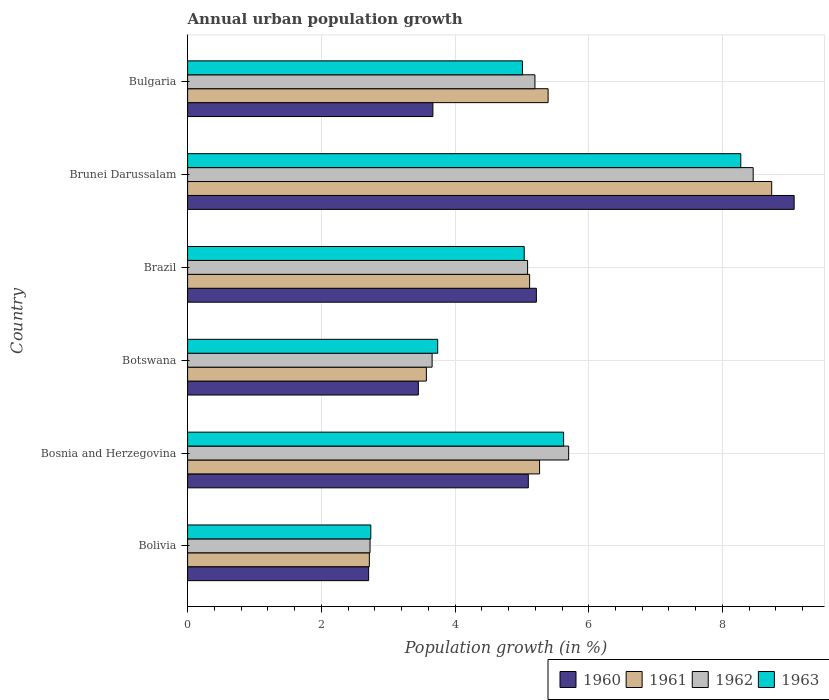How many different coloured bars are there?
Your answer should be very brief. 4. How many groups of bars are there?
Ensure brevity in your answer.  6. How many bars are there on the 6th tick from the bottom?
Offer a terse response. 4. What is the label of the 3rd group of bars from the top?
Keep it short and to the point. Brazil. What is the percentage of urban population growth in 1962 in Botswana?
Make the answer very short. 3.66. Across all countries, what is the maximum percentage of urban population growth in 1960?
Keep it short and to the point. 9.07. Across all countries, what is the minimum percentage of urban population growth in 1960?
Keep it short and to the point. 2.71. In which country was the percentage of urban population growth in 1960 maximum?
Your answer should be very brief. Brunei Darussalam. In which country was the percentage of urban population growth in 1960 minimum?
Provide a succinct answer. Bolivia. What is the total percentage of urban population growth in 1961 in the graph?
Your answer should be very brief. 30.8. What is the difference between the percentage of urban population growth in 1961 in Bosnia and Herzegovina and that in Botswana?
Your response must be concise. 1.69. What is the difference between the percentage of urban population growth in 1963 in Bulgaria and the percentage of urban population growth in 1960 in Bosnia and Herzegovina?
Offer a very short reply. -0.09. What is the average percentage of urban population growth in 1962 per country?
Provide a short and direct response. 5.14. What is the difference between the percentage of urban population growth in 1962 and percentage of urban population growth in 1961 in Bolivia?
Ensure brevity in your answer.  0.01. What is the ratio of the percentage of urban population growth in 1962 in Brazil to that in Brunei Darussalam?
Give a very brief answer. 0.6. Is the difference between the percentage of urban population growth in 1962 in Brunei Darussalam and Bulgaria greater than the difference between the percentage of urban population growth in 1961 in Brunei Darussalam and Bulgaria?
Keep it short and to the point. No. What is the difference between the highest and the second highest percentage of urban population growth in 1963?
Keep it short and to the point. 2.65. What is the difference between the highest and the lowest percentage of urban population growth in 1962?
Your answer should be compact. 5.73. In how many countries, is the percentage of urban population growth in 1962 greater than the average percentage of urban population growth in 1962 taken over all countries?
Make the answer very short. 3. Is it the case that in every country, the sum of the percentage of urban population growth in 1960 and percentage of urban population growth in 1962 is greater than the sum of percentage of urban population growth in 1961 and percentage of urban population growth in 1963?
Make the answer very short. No. How many bars are there?
Offer a terse response. 24. How many countries are there in the graph?
Your answer should be compact. 6. How many legend labels are there?
Provide a short and direct response. 4. How are the legend labels stacked?
Your answer should be compact. Horizontal. What is the title of the graph?
Make the answer very short. Annual urban population growth. What is the label or title of the X-axis?
Your answer should be compact. Population growth (in %). What is the Population growth (in %) in 1960 in Bolivia?
Give a very brief answer. 2.71. What is the Population growth (in %) in 1961 in Bolivia?
Your answer should be very brief. 2.72. What is the Population growth (in %) of 1962 in Bolivia?
Your answer should be very brief. 2.73. What is the Population growth (in %) in 1963 in Bolivia?
Your answer should be compact. 2.74. What is the Population growth (in %) of 1960 in Bosnia and Herzegovina?
Offer a very short reply. 5.1. What is the Population growth (in %) in 1961 in Bosnia and Herzegovina?
Your response must be concise. 5.26. What is the Population growth (in %) of 1962 in Bosnia and Herzegovina?
Provide a short and direct response. 5.7. What is the Population growth (in %) in 1963 in Bosnia and Herzegovina?
Your response must be concise. 5.62. What is the Population growth (in %) of 1960 in Botswana?
Offer a very short reply. 3.45. What is the Population growth (in %) in 1961 in Botswana?
Your answer should be compact. 3.57. What is the Population growth (in %) of 1962 in Botswana?
Your response must be concise. 3.66. What is the Population growth (in %) of 1963 in Botswana?
Keep it short and to the point. 3.74. What is the Population growth (in %) in 1960 in Brazil?
Ensure brevity in your answer.  5.22. What is the Population growth (in %) of 1961 in Brazil?
Give a very brief answer. 5.12. What is the Population growth (in %) of 1962 in Brazil?
Make the answer very short. 5.09. What is the Population growth (in %) in 1963 in Brazil?
Offer a terse response. 5.03. What is the Population growth (in %) in 1960 in Brunei Darussalam?
Ensure brevity in your answer.  9.07. What is the Population growth (in %) of 1961 in Brunei Darussalam?
Keep it short and to the point. 8.74. What is the Population growth (in %) of 1962 in Brunei Darussalam?
Offer a terse response. 8.46. What is the Population growth (in %) of 1963 in Brunei Darussalam?
Your response must be concise. 8.27. What is the Population growth (in %) in 1960 in Bulgaria?
Ensure brevity in your answer.  3.67. What is the Population growth (in %) of 1961 in Bulgaria?
Keep it short and to the point. 5.39. What is the Population growth (in %) in 1962 in Bulgaria?
Keep it short and to the point. 5.2. What is the Population growth (in %) in 1963 in Bulgaria?
Make the answer very short. 5.01. Across all countries, what is the maximum Population growth (in %) in 1960?
Give a very brief answer. 9.07. Across all countries, what is the maximum Population growth (in %) of 1961?
Keep it short and to the point. 8.74. Across all countries, what is the maximum Population growth (in %) in 1962?
Offer a terse response. 8.46. Across all countries, what is the maximum Population growth (in %) of 1963?
Your answer should be compact. 8.27. Across all countries, what is the minimum Population growth (in %) of 1960?
Your answer should be very brief. 2.71. Across all countries, what is the minimum Population growth (in %) of 1961?
Offer a terse response. 2.72. Across all countries, what is the minimum Population growth (in %) in 1962?
Offer a terse response. 2.73. Across all countries, what is the minimum Population growth (in %) of 1963?
Provide a succinct answer. 2.74. What is the total Population growth (in %) in 1960 in the graph?
Provide a short and direct response. 29.21. What is the total Population growth (in %) in 1961 in the graph?
Ensure brevity in your answer.  30.8. What is the total Population growth (in %) of 1962 in the graph?
Provide a short and direct response. 30.82. What is the total Population growth (in %) in 1963 in the graph?
Your answer should be compact. 30.42. What is the difference between the Population growth (in %) of 1960 in Bolivia and that in Bosnia and Herzegovina?
Your response must be concise. -2.39. What is the difference between the Population growth (in %) of 1961 in Bolivia and that in Bosnia and Herzegovina?
Provide a short and direct response. -2.55. What is the difference between the Population growth (in %) of 1962 in Bolivia and that in Bosnia and Herzegovina?
Give a very brief answer. -2.97. What is the difference between the Population growth (in %) of 1963 in Bolivia and that in Bosnia and Herzegovina?
Provide a succinct answer. -2.88. What is the difference between the Population growth (in %) of 1960 in Bolivia and that in Botswana?
Provide a succinct answer. -0.74. What is the difference between the Population growth (in %) in 1961 in Bolivia and that in Botswana?
Give a very brief answer. -0.85. What is the difference between the Population growth (in %) in 1962 in Bolivia and that in Botswana?
Provide a short and direct response. -0.93. What is the difference between the Population growth (in %) of 1963 in Bolivia and that in Botswana?
Your answer should be compact. -1. What is the difference between the Population growth (in %) in 1960 in Bolivia and that in Brazil?
Offer a terse response. -2.51. What is the difference between the Population growth (in %) of 1961 in Bolivia and that in Brazil?
Ensure brevity in your answer.  -2.4. What is the difference between the Population growth (in %) of 1962 in Bolivia and that in Brazil?
Make the answer very short. -2.36. What is the difference between the Population growth (in %) in 1963 in Bolivia and that in Brazil?
Your response must be concise. -2.29. What is the difference between the Population growth (in %) in 1960 in Bolivia and that in Brunei Darussalam?
Your answer should be compact. -6.36. What is the difference between the Population growth (in %) of 1961 in Bolivia and that in Brunei Darussalam?
Your answer should be compact. -6.02. What is the difference between the Population growth (in %) in 1962 in Bolivia and that in Brunei Darussalam?
Your response must be concise. -5.73. What is the difference between the Population growth (in %) of 1963 in Bolivia and that in Brunei Darussalam?
Your answer should be compact. -5.53. What is the difference between the Population growth (in %) of 1960 in Bolivia and that in Bulgaria?
Provide a short and direct response. -0.96. What is the difference between the Population growth (in %) in 1961 in Bolivia and that in Bulgaria?
Your answer should be compact. -2.67. What is the difference between the Population growth (in %) of 1962 in Bolivia and that in Bulgaria?
Provide a succinct answer. -2.47. What is the difference between the Population growth (in %) in 1963 in Bolivia and that in Bulgaria?
Provide a short and direct response. -2.27. What is the difference between the Population growth (in %) in 1960 in Bosnia and Herzegovina and that in Botswana?
Offer a very short reply. 1.64. What is the difference between the Population growth (in %) in 1961 in Bosnia and Herzegovina and that in Botswana?
Provide a short and direct response. 1.69. What is the difference between the Population growth (in %) of 1962 in Bosnia and Herzegovina and that in Botswana?
Make the answer very short. 2.04. What is the difference between the Population growth (in %) in 1963 in Bosnia and Herzegovina and that in Botswana?
Your response must be concise. 1.88. What is the difference between the Population growth (in %) of 1960 in Bosnia and Herzegovina and that in Brazil?
Provide a succinct answer. -0.12. What is the difference between the Population growth (in %) in 1961 in Bosnia and Herzegovina and that in Brazil?
Give a very brief answer. 0.15. What is the difference between the Population growth (in %) of 1962 in Bosnia and Herzegovina and that in Brazil?
Give a very brief answer. 0.61. What is the difference between the Population growth (in %) in 1963 in Bosnia and Herzegovina and that in Brazil?
Offer a terse response. 0.59. What is the difference between the Population growth (in %) of 1960 in Bosnia and Herzegovina and that in Brunei Darussalam?
Your answer should be compact. -3.98. What is the difference between the Population growth (in %) in 1961 in Bosnia and Herzegovina and that in Brunei Darussalam?
Your answer should be compact. -3.47. What is the difference between the Population growth (in %) of 1962 in Bosnia and Herzegovina and that in Brunei Darussalam?
Your answer should be compact. -2.76. What is the difference between the Population growth (in %) of 1963 in Bosnia and Herzegovina and that in Brunei Darussalam?
Keep it short and to the point. -2.65. What is the difference between the Population growth (in %) in 1960 in Bosnia and Herzegovina and that in Bulgaria?
Make the answer very short. 1.43. What is the difference between the Population growth (in %) in 1961 in Bosnia and Herzegovina and that in Bulgaria?
Offer a very short reply. -0.13. What is the difference between the Population growth (in %) of 1962 in Bosnia and Herzegovina and that in Bulgaria?
Give a very brief answer. 0.5. What is the difference between the Population growth (in %) of 1963 in Bosnia and Herzegovina and that in Bulgaria?
Provide a short and direct response. 0.62. What is the difference between the Population growth (in %) of 1960 in Botswana and that in Brazil?
Give a very brief answer. -1.76. What is the difference between the Population growth (in %) in 1961 in Botswana and that in Brazil?
Ensure brevity in your answer.  -1.54. What is the difference between the Population growth (in %) of 1962 in Botswana and that in Brazil?
Keep it short and to the point. -1.43. What is the difference between the Population growth (in %) of 1963 in Botswana and that in Brazil?
Your answer should be compact. -1.29. What is the difference between the Population growth (in %) of 1960 in Botswana and that in Brunei Darussalam?
Keep it short and to the point. -5.62. What is the difference between the Population growth (in %) in 1961 in Botswana and that in Brunei Darussalam?
Offer a very short reply. -5.16. What is the difference between the Population growth (in %) of 1962 in Botswana and that in Brunei Darussalam?
Offer a terse response. -4.8. What is the difference between the Population growth (in %) in 1963 in Botswana and that in Brunei Darussalam?
Keep it short and to the point. -4.53. What is the difference between the Population growth (in %) of 1960 in Botswana and that in Bulgaria?
Provide a succinct answer. -0.22. What is the difference between the Population growth (in %) of 1961 in Botswana and that in Bulgaria?
Your response must be concise. -1.82. What is the difference between the Population growth (in %) of 1962 in Botswana and that in Bulgaria?
Provide a succinct answer. -1.54. What is the difference between the Population growth (in %) in 1963 in Botswana and that in Bulgaria?
Provide a short and direct response. -1.27. What is the difference between the Population growth (in %) of 1960 in Brazil and that in Brunei Darussalam?
Keep it short and to the point. -3.86. What is the difference between the Population growth (in %) of 1961 in Brazil and that in Brunei Darussalam?
Provide a short and direct response. -3.62. What is the difference between the Population growth (in %) of 1962 in Brazil and that in Brunei Darussalam?
Your answer should be very brief. -3.37. What is the difference between the Population growth (in %) of 1963 in Brazil and that in Brunei Darussalam?
Make the answer very short. -3.24. What is the difference between the Population growth (in %) in 1960 in Brazil and that in Bulgaria?
Give a very brief answer. 1.55. What is the difference between the Population growth (in %) in 1961 in Brazil and that in Bulgaria?
Your response must be concise. -0.28. What is the difference between the Population growth (in %) in 1962 in Brazil and that in Bulgaria?
Make the answer very short. -0.11. What is the difference between the Population growth (in %) in 1963 in Brazil and that in Bulgaria?
Keep it short and to the point. 0.03. What is the difference between the Population growth (in %) of 1960 in Brunei Darussalam and that in Bulgaria?
Ensure brevity in your answer.  5.4. What is the difference between the Population growth (in %) of 1961 in Brunei Darussalam and that in Bulgaria?
Ensure brevity in your answer.  3.34. What is the difference between the Population growth (in %) of 1962 in Brunei Darussalam and that in Bulgaria?
Ensure brevity in your answer.  3.26. What is the difference between the Population growth (in %) in 1963 in Brunei Darussalam and that in Bulgaria?
Offer a very short reply. 3.27. What is the difference between the Population growth (in %) of 1960 in Bolivia and the Population growth (in %) of 1961 in Bosnia and Herzegovina?
Give a very brief answer. -2.56. What is the difference between the Population growth (in %) in 1960 in Bolivia and the Population growth (in %) in 1962 in Bosnia and Herzegovina?
Your answer should be very brief. -2.99. What is the difference between the Population growth (in %) in 1960 in Bolivia and the Population growth (in %) in 1963 in Bosnia and Herzegovina?
Provide a short and direct response. -2.92. What is the difference between the Population growth (in %) in 1961 in Bolivia and the Population growth (in %) in 1962 in Bosnia and Herzegovina?
Provide a short and direct response. -2.98. What is the difference between the Population growth (in %) of 1961 in Bolivia and the Population growth (in %) of 1963 in Bosnia and Herzegovina?
Ensure brevity in your answer.  -2.91. What is the difference between the Population growth (in %) in 1962 in Bolivia and the Population growth (in %) in 1963 in Bosnia and Herzegovina?
Provide a short and direct response. -2.9. What is the difference between the Population growth (in %) in 1960 in Bolivia and the Population growth (in %) in 1961 in Botswana?
Ensure brevity in your answer.  -0.86. What is the difference between the Population growth (in %) of 1960 in Bolivia and the Population growth (in %) of 1962 in Botswana?
Your answer should be very brief. -0.95. What is the difference between the Population growth (in %) in 1960 in Bolivia and the Population growth (in %) in 1963 in Botswana?
Your answer should be compact. -1.03. What is the difference between the Population growth (in %) of 1961 in Bolivia and the Population growth (in %) of 1962 in Botswana?
Ensure brevity in your answer.  -0.94. What is the difference between the Population growth (in %) of 1961 in Bolivia and the Population growth (in %) of 1963 in Botswana?
Give a very brief answer. -1.02. What is the difference between the Population growth (in %) in 1962 in Bolivia and the Population growth (in %) in 1963 in Botswana?
Give a very brief answer. -1.01. What is the difference between the Population growth (in %) of 1960 in Bolivia and the Population growth (in %) of 1961 in Brazil?
Offer a terse response. -2.41. What is the difference between the Population growth (in %) of 1960 in Bolivia and the Population growth (in %) of 1962 in Brazil?
Ensure brevity in your answer.  -2.38. What is the difference between the Population growth (in %) in 1960 in Bolivia and the Population growth (in %) in 1963 in Brazil?
Your response must be concise. -2.33. What is the difference between the Population growth (in %) in 1961 in Bolivia and the Population growth (in %) in 1962 in Brazil?
Provide a short and direct response. -2.37. What is the difference between the Population growth (in %) in 1961 in Bolivia and the Population growth (in %) in 1963 in Brazil?
Keep it short and to the point. -2.32. What is the difference between the Population growth (in %) in 1962 in Bolivia and the Population growth (in %) in 1963 in Brazil?
Provide a short and direct response. -2.31. What is the difference between the Population growth (in %) in 1960 in Bolivia and the Population growth (in %) in 1961 in Brunei Darussalam?
Make the answer very short. -6.03. What is the difference between the Population growth (in %) of 1960 in Bolivia and the Population growth (in %) of 1962 in Brunei Darussalam?
Give a very brief answer. -5.75. What is the difference between the Population growth (in %) of 1960 in Bolivia and the Population growth (in %) of 1963 in Brunei Darussalam?
Offer a terse response. -5.57. What is the difference between the Population growth (in %) in 1961 in Bolivia and the Population growth (in %) in 1962 in Brunei Darussalam?
Ensure brevity in your answer.  -5.74. What is the difference between the Population growth (in %) of 1961 in Bolivia and the Population growth (in %) of 1963 in Brunei Darussalam?
Keep it short and to the point. -5.56. What is the difference between the Population growth (in %) in 1962 in Bolivia and the Population growth (in %) in 1963 in Brunei Darussalam?
Your answer should be compact. -5.55. What is the difference between the Population growth (in %) in 1960 in Bolivia and the Population growth (in %) in 1961 in Bulgaria?
Your response must be concise. -2.68. What is the difference between the Population growth (in %) of 1960 in Bolivia and the Population growth (in %) of 1962 in Bulgaria?
Give a very brief answer. -2.49. What is the difference between the Population growth (in %) in 1960 in Bolivia and the Population growth (in %) in 1963 in Bulgaria?
Ensure brevity in your answer.  -2.3. What is the difference between the Population growth (in %) of 1961 in Bolivia and the Population growth (in %) of 1962 in Bulgaria?
Make the answer very short. -2.48. What is the difference between the Population growth (in %) of 1961 in Bolivia and the Population growth (in %) of 1963 in Bulgaria?
Give a very brief answer. -2.29. What is the difference between the Population growth (in %) in 1962 in Bolivia and the Population growth (in %) in 1963 in Bulgaria?
Provide a succinct answer. -2.28. What is the difference between the Population growth (in %) of 1960 in Bosnia and Herzegovina and the Population growth (in %) of 1961 in Botswana?
Offer a very short reply. 1.52. What is the difference between the Population growth (in %) of 1960 in Bosnia and Herzegovina and the Population growth (in %) of 1962 in Botswana?
Your response must be concise. 1.44. What is the difference between the Population growth (in %) in 1960 in Bosnia and Herzegovina and the Population growth (in %) in 1963 in Botswana?
Your response must be concise. 1.36. What is the difference between the Population growth (in %) of 1961 in Bosnia and Herzegovina and the Population growth (in %) of 1962 in Botswana?
Provide a succinct answer. 1.61. What is the difference between the Population growth (in %) of 1961 in Bosnia and Herzegovina and the Population growth (in %) of 1963 in Botswana?
Keep it short and to the point. 1.52. What is the difference between the Population growth (in %) of 1962 in Bosnia and Herzegovina and the Population growth (in %) of 1963 in Botswana?
Your response must be concise. 1.96. What is the difference between the Population growth (in %) of 1960 in Bosnia and Herzegovina and the Population growth (in %) of 1961 in Brazil?
Make the answer very short. -0.02. What is the difference between the Population growth (in %) of 1960 in Bosnia and Herzegovina and the Population growth (in %) of 1962 in Brazil?
Keep it short and to the point. 0.01. What is the difference between the Population growth (in %) of 1960 in Bosnia and Herzegovina and the Population growth (in %) of 1963 in Brazil?
Your response must be concise. 0.06. What is the difference between the Population growth (in %) in 1961 in Bosnia and Herzegovina and the Population growth (in %) in 1962 in Brazil?
Offer a very short reply. 0.18. What is the difference between the Population growth (in %) in 1961 in Bosnia and Herzegovina and the Population growth (in %) in 1963 in Brazil?
Your answer should be compact. 0.23. What is the difference between the Population growth (in %) in 1962 in Bosnia and Herzegovina and the Population growth (in %) in 1963 in Brazil?
Make the answer very short. 0.66. What is the difference between the Population growth (in %) in 1960 in Bosnia and Herzegovina and the Population growth (in %) in 1961 in Brunei Darussalam?
Keep it short and to the point. -3.64. What is the difference between the Population growth (in %) of 1960 in Bosnia and Herzegovina and the Population growth (in %) of 1962 in Brunei Darussalam?
Your response must be concise. -3.36. What is the difference between the Population growth (in %) in 1960 in Bosnia and Herzegovina and the Population growth (in %) in 1963 in Brunei Darussalam?
Your response must be concise. -3.18. What is the difference between the Population growth (in %) of 1961 in Bosnia and Herzegovina and the Population growth (in %) of 1962 in Brunei Darussalam?
Your answer should be very brief. -3.19. What is the difference between the Population growth (in %) of 1961 in Bosnia and Herzegovina and the Population growth (in %) of 1963 in Brunei Darussalam?
Provide a short and direct response. -3.01. What is the difference between the Population growth (in %) of 1962 in Bosnia and Herzegovina and the Population growth (in %) of 1963 in Brunei Darussalam?
Your answer should be very brief. -2.57. What is the difference between the Population growth (in %) in 1960 in Bosnia and Herzegovina and the Population growth (in %) in 1961 in Bulgaria?
Your answer should be compact. -0.3. What is the difference between the Population growth (in %) in 1960 in Bosnia and Herzegovina and the Population growth (in %) in 1962 in Bulgaria?
Your response must be concise. -0.1. What is the difference between the Population growth (in %) in 1960 in Bosnia and Herzegovina and the Population growth (in %) in 1963 in Bulgaria?
Make the answer very short. 0.09. What is the difference between the Population growth (in %) of 1961 in Bosnia and Herzegovina and the Population growth (in %) of 1962 in Bulgaria?
Provide a succinct answer. 0.07. What is the difference between the Population growth (in %) in 1961 in Bosnia and Herzegovina and the Population growth (in %) in 1963 in Bulgaria?
Your response must be concise. 0.26. What is the difference between the Population growth (in %) in 1962 in Bosnia and Herzegovina and the Population growth (in %) in 1963 in Bulgaria?
Your answer should be compact. 0.69. What is the difference between the Population growth (in %) of 1960 in Botswana and the Population growth (in %) of 1961 in Brazil?
Make the answer very short. -1.66. What is the difference between the Population growth (in %) in 1960 in Botswana and the Population growth (in %) in 1962 in Brazil?
Offer a terse response. -1.63. What is the difference between the Population growth (in %) in 1960 in Botswana and the Population growth (in %) in 1963 in Brazil?
Your answer should be compact. -1.58. What is the difference between the Population growth (in %) of 1961 in Botswana and the Population growth (in %) of 1962 in Brazil?
Your answer should be compact. -1.51. What is the difference between the Population growth (in %) in 1961 in Botswana and the Population growth (in %) in 1963 in Brazil?
Provide a short and direct response. -1.46. What is the difference between the Population growth (in %) of 1962 in Botswana and the Population growth (in %) of 1963 in Brazil?
Your response must be concise. -1.38. What is the difference between the Population growth (in %) of 1960 in Botswana and the Population growth (in %) of 1961 in Brunei Darussalam?
Your answer should be compact. -5.28. What is the difference between the Population growth (in %) of 1960 in Botswana and the Population growth (in %) of 1962 in Brunei Darussalam?
Your answer should be compact. -5.01. What is the difference between the Population growth (in %) of 1960 in Botswana and the Population growth (in %) of 1963 in Brunei Darussalam?
Offer a very short reply. -4.82. What is the difference between the Population growth (in %) in 1961 in Botswana and the Population growth (in %) in 1962 in Brunei Darussalam?
Keep it short and to the point. -4.89. What is the difference between the Population growth (in %) in 1961 in Botswana and the Population growth (in %) in 1963 in Brunei Darussalam?
Provide a succinct answer. -4.7. What is the difference between the Population growth (in %) in 1962 in Botswana and the Population growth (in %) in 1963 in Brunei Darussalam?
Provide a succinct answer. -4.62. What is the difference between the Population growth (in %) of 1960 in Botswana and the Population growth (in %) of 1961 in Bulgaria?
Offer a very short reply. -1.94. What is the difference between the Population growth (in %) of 1960 in Botswana and the Population growth (in %) of 1962 in Bulgaria?
Ensure brevity in your answer.  -1.74. What is the difference between the Population growth (in %) of 1960 in Botswana and the Population growth (in %) of 1963 in Bulgaria?
Make the answer very short. -1.56. What is the difference between the Population growth (in %) of 1961 in Botswana and the Population growth (in %) of 1962 in Bulgaria?
Offer a terse response. -1.62. What is the difference between the Population growth (in %) in 1961 in Botswana and the Population growth (in %) in 1963 in Bulgaria?
Your answer should be very brief. -1.44. What is the difference between the Population growth (in %) in 1962 in Botswana and the Population growth (in %) in 1963 in Bulgaria?
Your answer should be very brief. -1.35. What is the difference between the Population growth (in %) in 1960 in Brazil and the Population growth (in %) in 1961 in Brunei Darussalam?
Ensure brevity in your answer.  -3.52. What is the difference between the Population growth (in %) of 1960 in Brazil and the Population growth (in %) of 1962 in Brunei Darussalam?
Offer a terse response. -3.24. What is the difference between the Population growth (in %) of 1960 in Brazil and the Population growth (in %) of 1963 in Brunei Darussalam?
Provide a succinct answer. -3.06. What is the difference between the Population growth (in %) of 1961 in Brazil and the Population growth (in %) of 1962 in Brunei Darussalam?
Your answer should be very brief. -3.34. What is the difference between the Population growth (in %) of 1961 in Brazil and the Population growth (in %) of 1963 in Brunei Darussalam?
Give a very brief answer. -3.16. What is the difference between the Population growth (in %) in 1962 in Brazil and the Population growth (in %) in 1963 in Brunei Darussalam?
Provide a short and direct response. -3.19. What is the difference between the Population growth (in %) of 1960 in Brazil and the Population growth (in %) of 1961 in Bulgaria?
Keep it short and to the point. -0.18. What is the difference between the Population growth (in %) of 1960 in Brazil and the Population growth (in %) of 1962 in Bulgaria?
Ensure brevity in your answer.  0.02. What is the difference between the Population growth (in %) of 1960 in Brazil and the Population growth (in %) of 1963 in Bulgaria?
Give a very brief answer. 0.21. What is the difference between the Population growth (in %) in 1961 in Brazil and the Population growth (in %) in 1962 in Bulgaria?
Ensure brevity in your answer.  -0.08. What is the difference between the Population growth (in %) of 1961 in Brazil and the Population growth (in %) of 1963 in Bulgaria?
Provide a succinct answer. 0.11. What is the difference between the Population growth (in %) of 1962 in Brazil and the Population growth (in %) of 1963 in Bulgaria?
Your answer should be compact. 0.08. What is the difference between the Population growth (in %) in 1960 in Brunei Darussalam and the Population growth (in %) in 1961 in Bulgaria?
Keep it short and to the point. 3.68. What is the difference between the Population growth (in %) of 1960 in Brunei Darussalam and the Population growth (in %) of 1962 in Bulgaria?
Your answer should be compact. 3.88. What is the difference between the Population growth (in %) of 1960 in Brunei Darussalam and the Population growth (in %) of 1963 in Bulgaria?
Your answer should be very brief. 4.06. What is the difference between the Population growth (in %) of 1961 in Brunei Darussalam and the Population growth (in %) of 1962 in Bulgaria?
Keep it short and to the point. 3.54. What is the difference between the Population growth (in %) in 1961 in Brunei Darussalam and the Population growth (in %) in 1963 in Bulgaria?
Offer a terse response. 3.73. What is the difference between the Population growth (in %) in 1962 in Brunei Darussalam and the Population growth (in %) in 1963 in Bulgaria?
Ensure brevity in your answer.  3.45. What is the average Population growth (in %) in 1960 per country?
Your answer should be compact. 4.87. What is the average Population growth (in %) of 1961 per country?
Keep it short and to the point. 5.13. What is the average Population growth (in %) of 1962 per country?
Keep it short and to the point. 5.14. What is the average Population growth (in %) of 1963 per country?
Ensure brevity in your answer.  5.07. What is the difference between the Population growth (in %) of 1960 and Population growth (in %) of 1961 in Bolivia?
Give a very brief answer. -0.01. What is the difference between the Population growth (in %) in 1960 and Population growth (in %) in 1962 in Bolivia?
Your answer should be very brief. -0.02. What is the difference between the Population growth (in %) in 1960 and Population growth (in %) in 1963 in Bolivia?
Your answer should be very brief. -0.03. What is the difference between the Population growth (in %) of 1961 and Population growth (in %) of 1962 in Bolivia?
Offer a very short reply. -0.01. What is the difference between the Population growth (in %) in 1961 and Population growth (in %) in 1963 in Bolivia?
Offer a very short reply. -0.02. What is the difference between the Population growth (in %) of 1962 and Population growth (in %) of 1963 in Bolivia?
Your answer should be very brief. -0.01. What is the difference between the Population growth (in %) in 1960 and Population growth (in %) in 1961 in Bosnia and Herzegovina?
Your answer should be very brief. -0.17. What is the difference between the Population growth (in %) in 1960 and Population growth (in %) in 1962 in Bosnia and Herzegovina?
Your answer should be very brief. -0.6. What is the difference between the Population growth (in %) of 1960 and Population growth (in %) of 1963 in Bosnia and Herzegovina?
Keep it short and to the point. -0.53. What is the difference between the Population growth (in %) of 1961 and Population growth (in %) of 1962 in Bosnia and Herzegovina?
Offer a very short reply. -0.43. What is the difference between the Population growth (in %) in 1961 and Population growth (in %) in 1963 in Bosnia and Herzegovina?
Your answer should be compact. -0.36. What is the difference between the Population growth (in %) in 1962 and Population growth (in %) in 1963 in Bosnia and Herzegovina?
Ensure brevity in your answer.  0.08. What is the difference between the Population growth (in %) in 1960 and Population growth (in %) in 1961 in Botswana?
Keep it short and to the point. -0.12. What is the difference between the Population growth (in %) of 1960 and Population growth (in %) of 1962 in Botswana?
Your answer should be compact. -0.21. What is the difference between the Population growth (in %) of 1960 and Population growth (in %) of 1963 in Botswana?
Your answer should be very brief. -0.29. What is the difference between the Population growth (in %) of 1961 and Population growth (in %) of 1962 in Botswana?
Your response must be concise. -0.09. What is the difference between the Population growth (in %) of 1961 and Population growth (in %) of 1963 in Botswana?
Provide a succinct answer. -0.17. What is the difference between the Population growth (in %) of 1962 and Population growth (in %) of 1963 in Botswana?
Your answer should be compact. -0.08. What is the difference between the Population growth (in %) of 1960 and Population growth (in %) of 1961 in Brazil?
Make the answer very short. 0.1. What is the difference between the Population growth (in %) of 1960 and Population growth (in %) of 1962 in Brazil?
Keep it short and to the point. 0.13. What is the difference between the Population growth (in %) in 1960 and Population growth (in %) in 1963 in Brazil?
Give a very brief answer. 0.18. What is the difference between the Population growth (in %) in 1961 and Population growth (in %) in 1962 in Brazil?
Offer a terse response. 0.03. What is the difference between the Population growth (in %) of 1961 and Population growth (in %) of 1963 in Brazil?
Give a very brief answer. 0.08. What is the difference between the Population growth (in %) of 1962 and Population growth (in %) of 1963 in Brazil?
Keep it short and to the point. 0.05. What is the difference between the Population growth (in %) in 1960 and Population growth (in %) in 1961 in Brunei Darussalam?
Keep it short and to the point. 0.34. What is the difference between the Population growth (in %) of 1960 and Population growth (in %) of 1962 in Brunei Darussalam?
Provide a succinct answer. 0.61. What is the difference between the Population growth (in %) in 1960 and Population growth (in %) in 1963 in Brunei Darussalam?
Provide a short and direct response. 0.8. What is the difference between the Population growth (in %) of 1961 and Population growth (in %) of 1962 in Brunei Darussalam?
Provide a succinct answer. 0.28. What is the difference between the Population growth (in %) in 1961 and Population growth (in %) in 1963 in Brunei Darussalam?
Offer a very short reply. 0.46. What is the difference between the Population growth (in %) in 1962 and Population growth (in %) in 1963 in Brunei Darussalam?
Offer a terse response. 0.19. What is the difference between the Population growth (in %) of 1960 and Population growth (in %) of 1961 in Bulgaria?
Make the answer very short. -1.72. What is the difference between the Population growth (in %) in 1960 and Population growth (in %) in 1962 in Bulgaria?
Offer a terse response. -1.53. What is the difference between the Population growth (in %) in 1960 and Population growth (in %) in 1963 in Bulgaria?
Your response must be concise. -1.34. What is the difference between the Population growth (in %) in 1961 and Population growth (in %) in 1962 in Bulgaria?
Offer a very short reply. 0.2. What is the difference between the Population growth (in %) of 1961 and Population growth (in %) of 1963 in Bulgaria?
Your answer should be compact. 0.38. What is the difference between the Population growth (in %) of 1962 and Population growth (in %) of 1963 in Bulgaria?
Your answer should be compact. 0.19. What is the ratio of the Population growth (in %) of 1960 in Bolivia to that in Bosnia and Herzegovina?
Your response must be concise. 0.53. What is the ratio of the Population growth (in %) of 1961 in Bolivia to that in Bosnia and Herzegovina?
Your response must be concise. 0.52. What is the ratio of the Population growth (in %) of 1962 in Bolivia to that in Bosnia and Herzegovina?
Ensure brevity in your answer.  0.48. What is the ratio of the Population growth (in %) in 1963 in Bolivia to that in Bosnia and Herzegovina?
Offer a terse response. 0.49. What is the ratio of the Population growth (in %) of 1960 in Bolivia to that in Botswana?
Your answer should be very brief. 0.78. What is the ratio of the Population growth (in %) in 1961 in Bolivia to that in Botswana?
Ensure brevity in your answer.  0.76. What is the ratio of the Population growth (in %) of 1962 in Bolivia to that in Botswana?
Keep it short and to the point. 0.75. What is the ratio of the Population growth (in %) in 1963 in Bolivia to that in Botswana?
Ensure brevity in your answer.  0.73. What is the ratio of the Population growth (in %) in 1960 in Bolivia to that in Brazil?
Provide a short and direct response. 0.52. What is the ratio of the Population growth (in %) of 1961 in Bolivia to that in Brazil?
Make the answer very short. 0.53. What is the ratio of the Population growth (in %) in 1962 in Bolivia to that in Brazil?
Make the answer very short. 0.54. What is the ratio of the Population growth (in %) of 1963 in Bolivia to that in Brazil?
Provide a succinct answer. 0.54. What is the ratio of the Population growth (in %) in 1960 in Bolivia to that in Brunei Darussalam?
Ensure brevity in your answer.  0.3. What is the ratio of the Population growth (in %) of 1961 in Bolivia to that in Brunei Darussalam?
Make the answer very short. 0.31. What is the ratio of the Population growth (in %) in 1962 in Bolivia to that in Brunei Darussalam?
Provide a short and direct response. 0.32. What is the ratio of the Population growth (in %) of 1963 in Bolivia to that in Brunei Darussalam?
Make the answer very short. 0.33. What is the ratio of the Population growth (in %) in 1960 in Bolivia to that in Bulgaria?
Offer a terse response. 0.74. What is the ratio of the Population growth (in %) in 1961 in Bolivia to that in Bulgaria?
Offer a terse response. 0.5. What is the ratio of the Population growth (in %) in 1962 in Bolivia to that in Bulgaria?
Your answer should be very brief. 0.53. What is the ratio of the Population growth (in %) of 1963 in Bolivia to that in Bulgaria?
Provide a succinct answer. 0.55. What is the ratio of the Population growth (in %) of 1960 in Bosnia and Herzegovina to that in Botswana?
Your answer should be very brief. 1.48. What is the ratio of the Population growth (in %) of 1961 in Bosnia and Herzegovina to that in Botswana?
Provide a succinct answer. 1.47. What is the ratio of the Population growth (in %) in 1962 in Bosnia and Herzegovina to that in Botswana?
Your answer should be very brief. 1.56. What is the ratio of the Population growth (in %) of 1963 in Bosnia and Herzegovina to that in Botswana?
Give a very brief answer. 1.5. What is the ratio of the Population growth (in %) of 1960 in Bosnia and Herzegovina to that in Brazil?
Offer a terse response. 0.98. What is the ratio of the Population growth (in %) of 1961 in Bosnia and Herzegovina to that in Brazil?
Ensure brevity in your answer.  1.03. What is the ratio of the Population growth (in %) in 1962 in Bosnia and Herzegovina to that in Brazil?
Your response must be concise. 1.12. What is the ratio of the Population growth (in %) of 1963 in Bosnia and Herzegovina to that in Brazil?
Offer a very short reply. 1.12. What is the ratio of the Population growth (in %) of 1960 in Bosnia and Herzegovina to that in Brunei Darussalam?
Give a very brief answer. 0.56. What is the ratio of the Population growth (in %) of 1961 in Bosnia and Herzegovina to that in Brunei Darussalam?
Keep it short and to the point. 0.6. What is the ratio of the Population growth (in %) in 1962 in Bosnia and Herzegovina to that in Brunei Darussalam?
Your answer should be very brief. 0.67. What is the ratio of the Population growth (in %) of 1963 in Bosnia and Herzegovina to that in Brunei Darussalam?
Offer a very short reply. 0.68. What is the ratio of the Population growth (in %) in 1960 in Bosnia and Herzegovina to that in Bulgaria?
Offer a very short reply. 1.39. What is the ratio of the Population growth (in %) of 1961 in Bosnia and Herzegovina to that in Bulgaria?
Make the answer very short. 0.98. What is the ratio of the Population growth (in %) of 1962 in Bosnia and Herzegovina to that in Bulgaria?
Offer a terse response. 1.1. What is the ratio of the Population growth (in %) in 1963 in Bosnia and Herzegovina to that in Bulgaria?
Offer a very short reply. 1.12. What is the ratio of the Population growth (in %) of 1960 in Botswana to that in Brazil?
Your answer should be compact. 0.66. What is the ratio of the Population growth (in %) in 1961 in Botswana to that in Brazil?
Provide a short and direct response. 0.7. What is the ratio of the Population growth (in %) in 1962 in Botswana to that in Brazil?
Offer a very short reply. 0.72. What is the ratio of the Population growth (in %) in 1963 in Botswana to that in Brazil?
Make the answer very short. 0.74. What is the ratio of the Population growth (in %) in 1960 in Botswana to that in Brunei Darussalam?
Your answer should be compact. 0.38. What is the ratio of the Population growth (in %) in 1961 in Botswana to that in Brunei Darussalam?
Provide a short and direct response. 0.41. What is the ratio of the Population growth (in %) of 1962 in Botswana to that in Brunei Darussalam?
Your answer should be very brief. 0.43. What is the ratio of the Population growth (in %) in 1963 in Botswana to that in Brunei Darussalam?
Provide a succinct answer. 0.45. What is the ratio of the Population growth (in %) in 1960 in Botswana to that in Bulgaria?
Keep it short and to the point. 0.94. What is the ratio of the Population growth (in %) of 1961 in Botswana to that in Bulgaria?
Give a very brief answer. 0.66. What is the ratio of the Population growth (in %) of 1962 in Botswana to that in Bulgaria?
Give a very brief answer. 0.7. What is the ratio of the Population growth (in %) of 1963 in Botswana to that in Bulgaria?
Your response must be concise. 0.75. What is the ratio of the Population growth (in %) in 1960 in Brazil to that in Brunei Darussalam?
Keep it short and to the point. 0.57. What is the ratio of the Population growth (in %) of 1961 in Brazil to that in Brunei Darussalam?
Provide a succinct answer. 0.59. What is the ratio of the Population growth (in %) in 1962 in Brazil to that in Brunei Darussalam?
Your answer should be compact. 0.6. What is the ratio of the Population growth (in %) in 1963 in Brazil to that in Brunei Darussalam?
Offer a very short reply. 0.61. What is the ratio of the Population growth (in %) in 1960 in Brazil to that in Bulgaria?
Keep it short and to the point. 1.42. What is the ratio of the Population growth (in %) in 1961 in Brazil to that in Bulgaria?
Keep it short and to the point. 0.95. What is the ratio of the Population growth (in %) in 1962 in Brazil to that in Bulgaria?
Keep it short and to the point. 0.98. What is the ratio of the Population growth (in %) of 1960 in Brunei Darussalam to that in Bulgaria?
Offer a very short reply. 2.47. What is the ratio of the Population growth (in %) in 1961 in Brunei Darussalam to that in Bulgaria?
Offer a terse response. 1.62. What is the ratio of the Population growth (in %) in 1962 in Brunei Darussalam to that in Bulgaria?
Provide a short and direct response. 1.63. What is the ratio of the Population growth (in %) of 1963 in Brunei Darussalam to that in Bulgaria?
Your answer should be very brief. 1.65. What is the difference between the highest and the second highest Population growth (in %) of 1960?
Your response must be concise. 3.86. What is the difference between the highest and the second highest Population growth (in %) of 1961?
Make the answer very short. 3.34. What is the difference between the highest and the second highest Population growth (in %) of 1962?
Provide a short and direct response. 2.76. What is the difference between the highest and the second highest Population growth (in %) of 1963?
Make the answer very short. 2.65. What is the difference between the highest and the lowest Population growth (in %) in 1960?
Make the answer very short. 6.36. What is the difference between the highest and the lowest Population growth (in %) in 1961?
Your answer should be compact. 6.02. What is the difference between the highest and the lowest Population growth (in %) of 1962?
Offer a very short reply. 5.73. What is the difference between the highest and the lowest Population growth (in %) of 1963?
Provide a short and direct response. 5.53. 